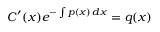Convert formula to latex. <formula><loc_0><loc_0><loc_500><loc_500>C ^ { \prime } ( x ) e ^ { - \int p ( x ) \, d x } = q ( x )</formula> 